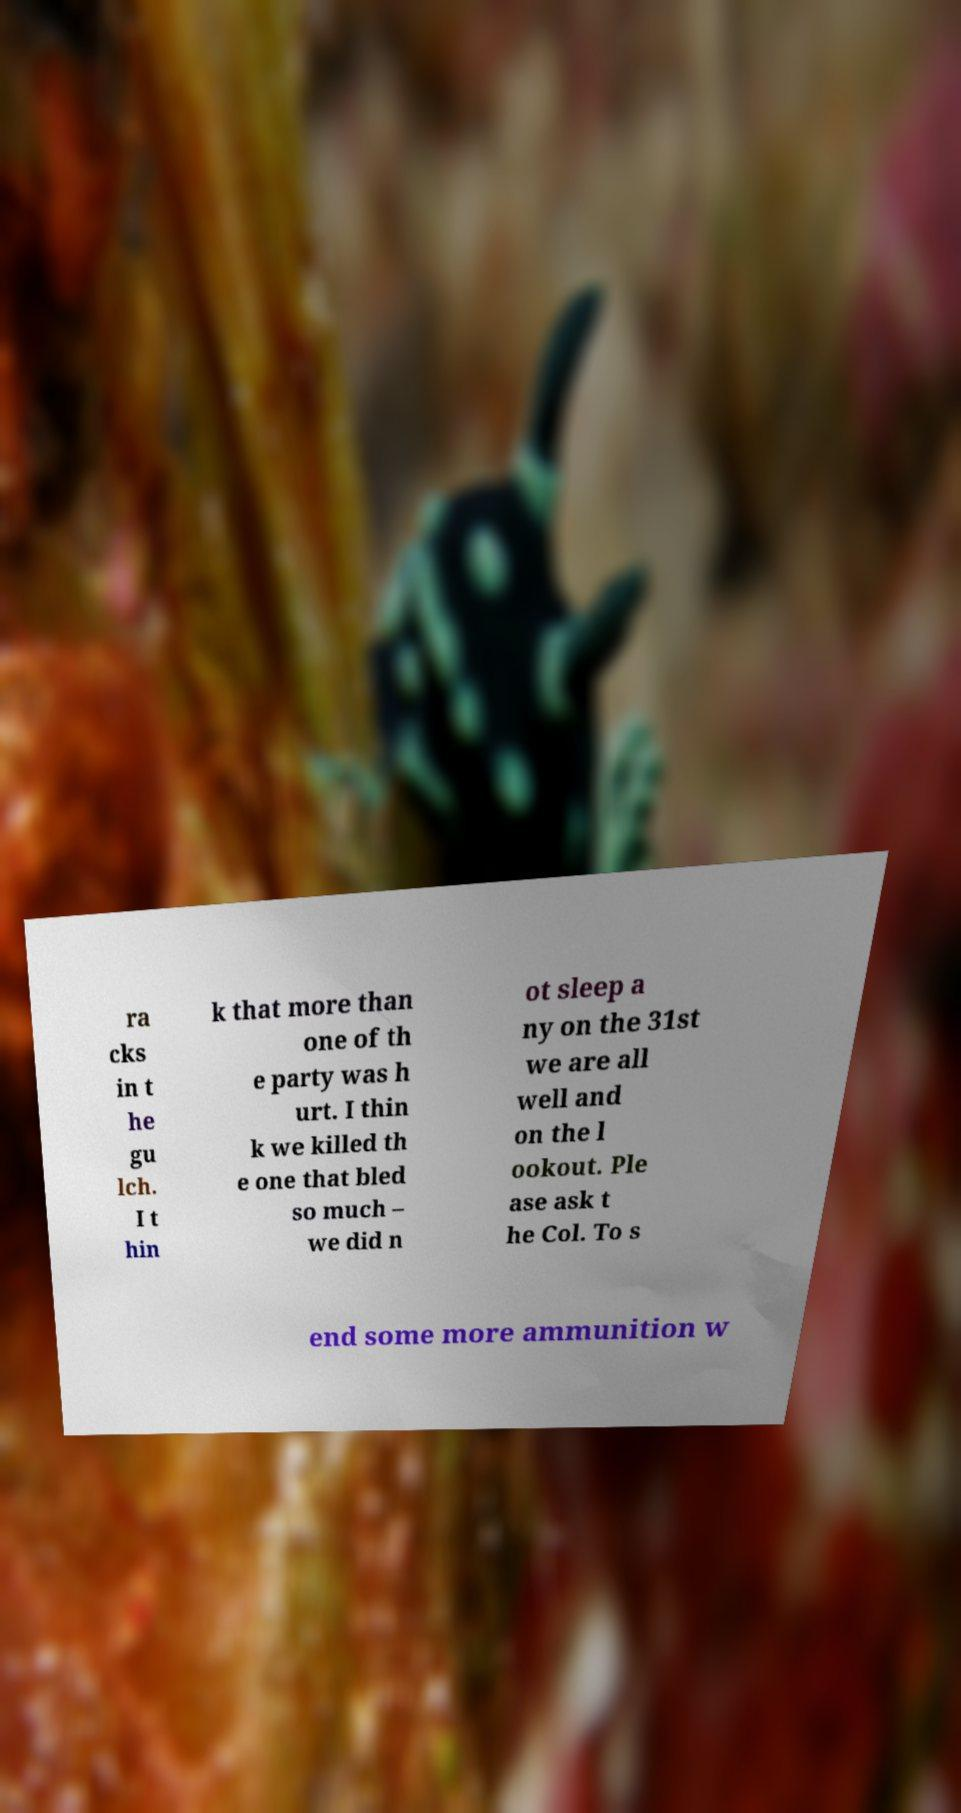I need the written content from this picture converted into text. Can you do that? ra cks in t he gu lch. I t hin k that more than one of th e party was h urt. I thin k we killed th e one that bled so much – we did n ot sleep a ny on the 31st we are all well and on the l ookout. Ple ase ask t he Col. To s end some more ammunition w 